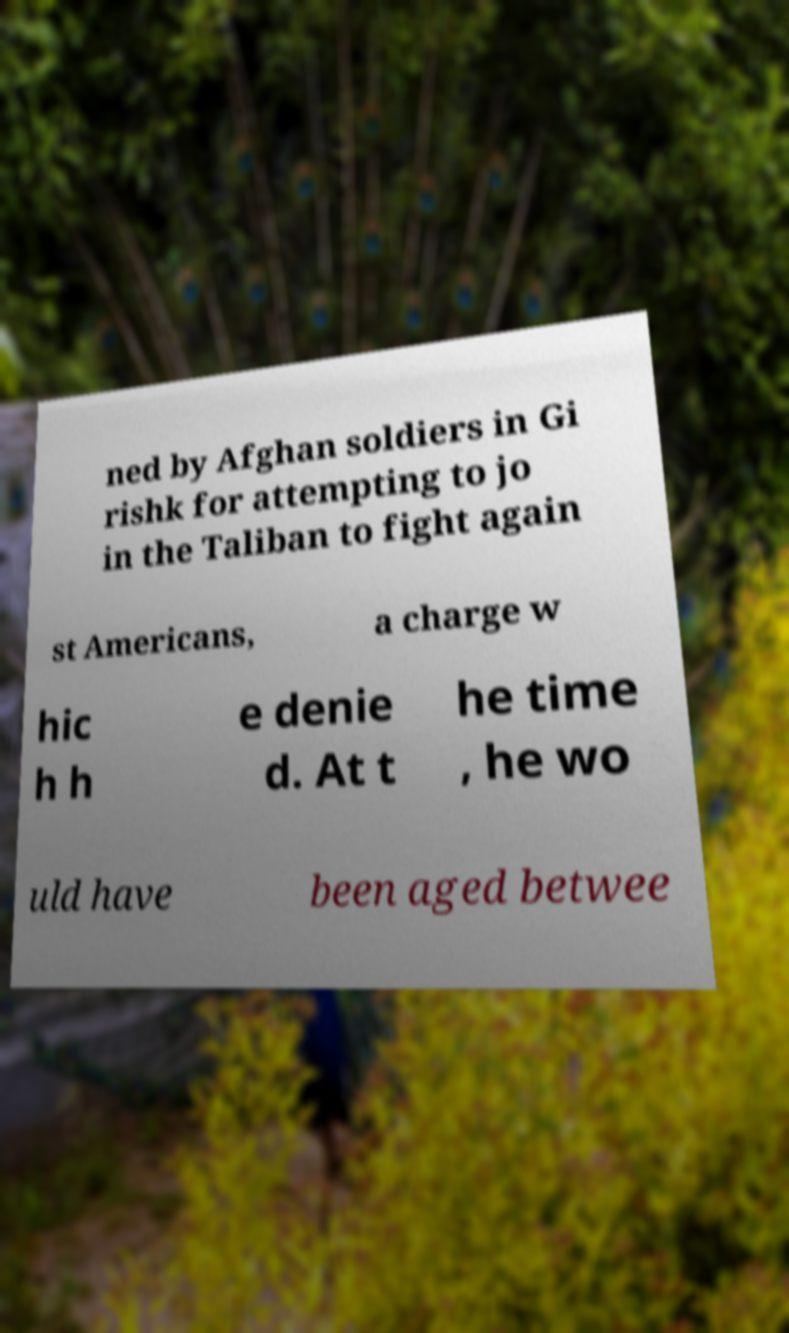What messages or text are displayed in this image? I need them in a readable, typed format. ned by Afghan soldiers in Gi rishk for attempting to jo in the Taliban to fight again st Americans, a charge w hic h h e denie d. At t he time , he wo uld have been aged betwee 